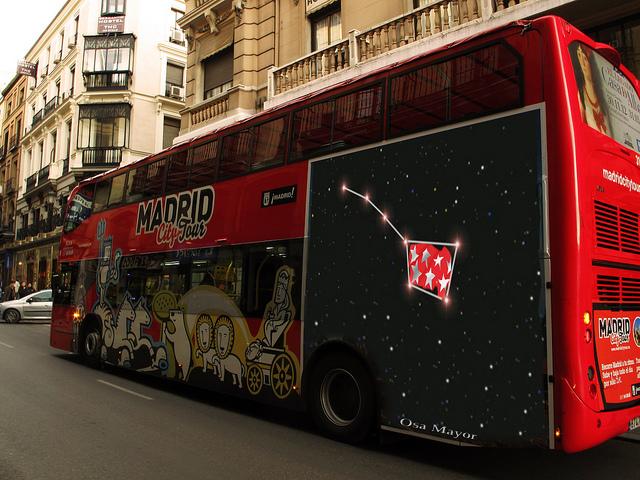In what country the bus riding?
Concise answer only. Spain. Could the country be Espana?
Short answer required. Yes. How many floors in this bus?
Be succinct. 2. 